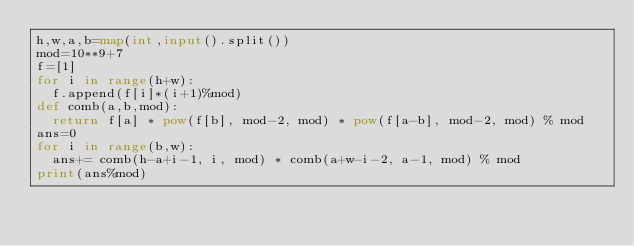<code> <loc_0><loc_0><loc_500><loc_500><_Python_>h,w,a,b=map(int,input().split())
mod=10**9+7
f=[1]
for i in range(h+w):
  f.append(f[i]*(i+1)%mod)
def comb(a,b,mod):
  return f[a] * pow(f[b], mod-2, mod) * pow(f[a-b], mod-2, mod) % mod
ans=0
for i in range(b,w):
  ans+= comb(h-a+i-1, i, mod) * comb(a+w-i-2, a-1, mod) % mod
print(ans%mod)</code> 